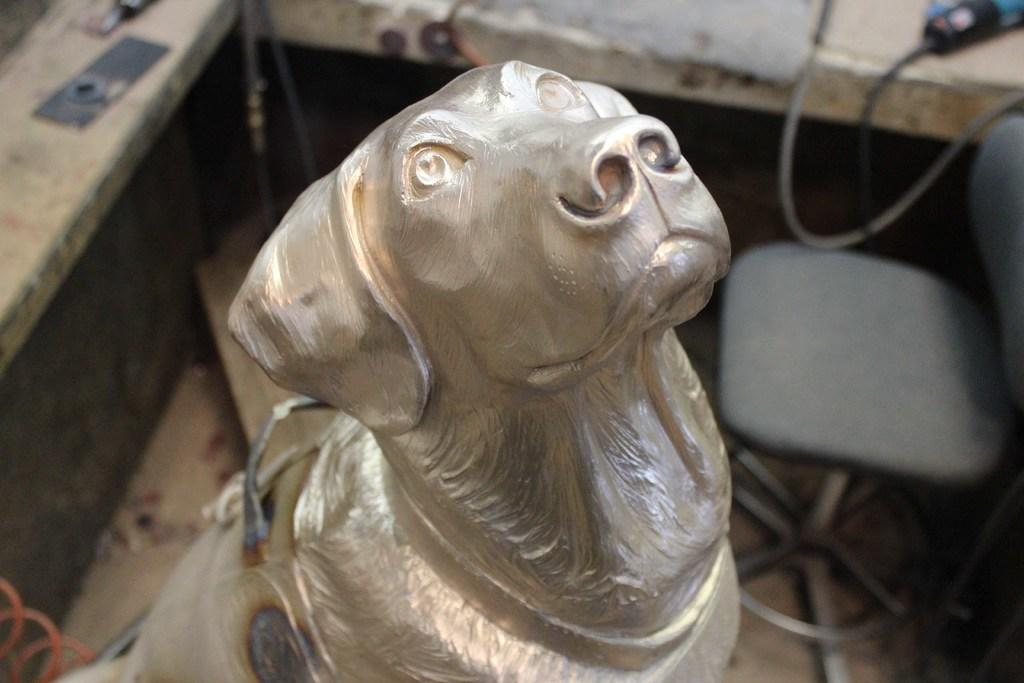What is the main subject of the image? There is a sculpture of a dog in the image. What type of furniture is present in the image? There is a chair in the image. Is there any additional feature in front of the chair? Yes, there is a platform in front of the chair. What type of seed is being planted on the platform in the image? There is no seed or planting activity depicted in the image; it features a sculpture of a dog, a chair, and a platform. 